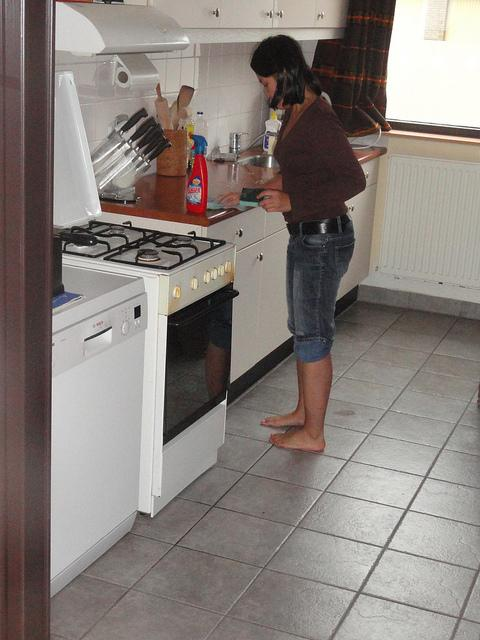How are dishes cleaned here? dishwasher 